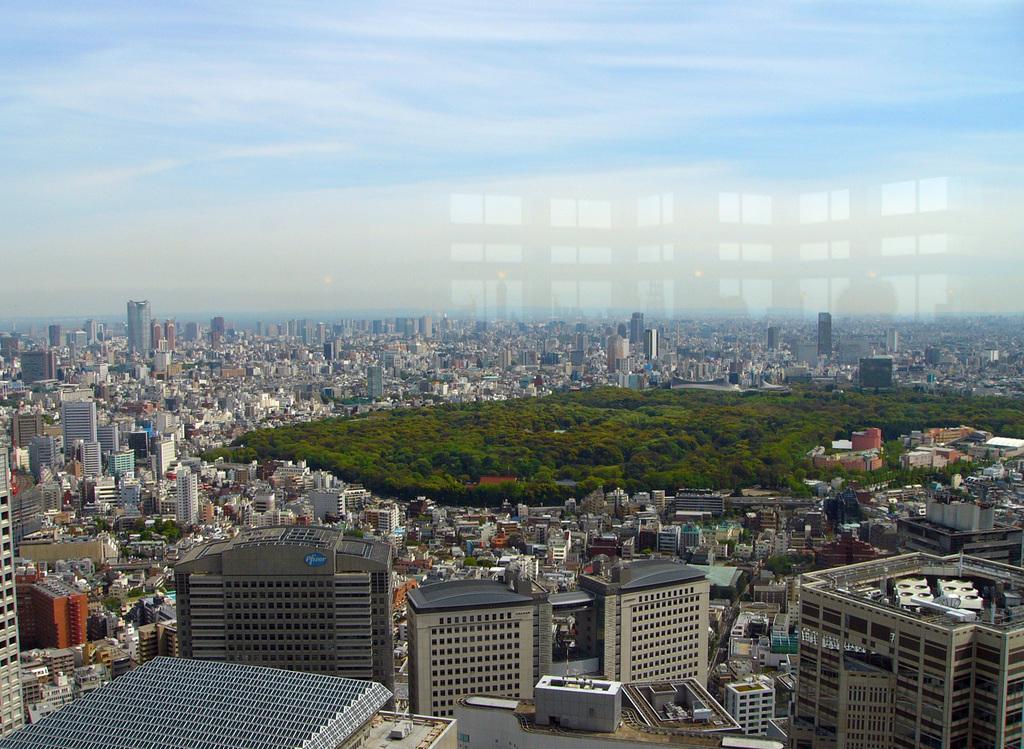Can you describe this image briefly? In the image in the center we can see buildings,wall,trees and plants. In the background there is a sky and clouds. 